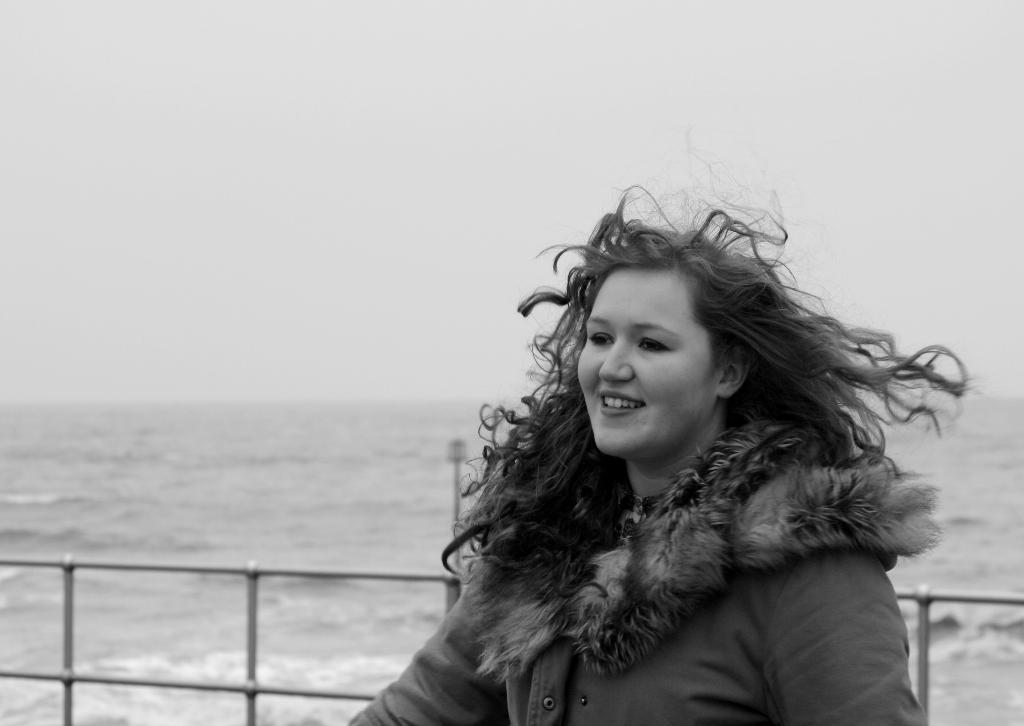What is the color scheme of the image? The image is black and white. Who is present in the image? There is a woman in the image. What is the woman standing in front of? The woman is standing in front of a sea. What is behind the woman in the image? There is a fencing behind the woman. What is the woman wearing? The woman is wearing a jacket. What is the woman's facial expression? The woman is smiling. What type of lipstick is the woman wearing in the image? The image is black and white, so it is not possible to determine the type of lipstick the woman might be wearing. What type of scarf is the woman wearing in the image? The woman is not wearing a scarf in the image. 